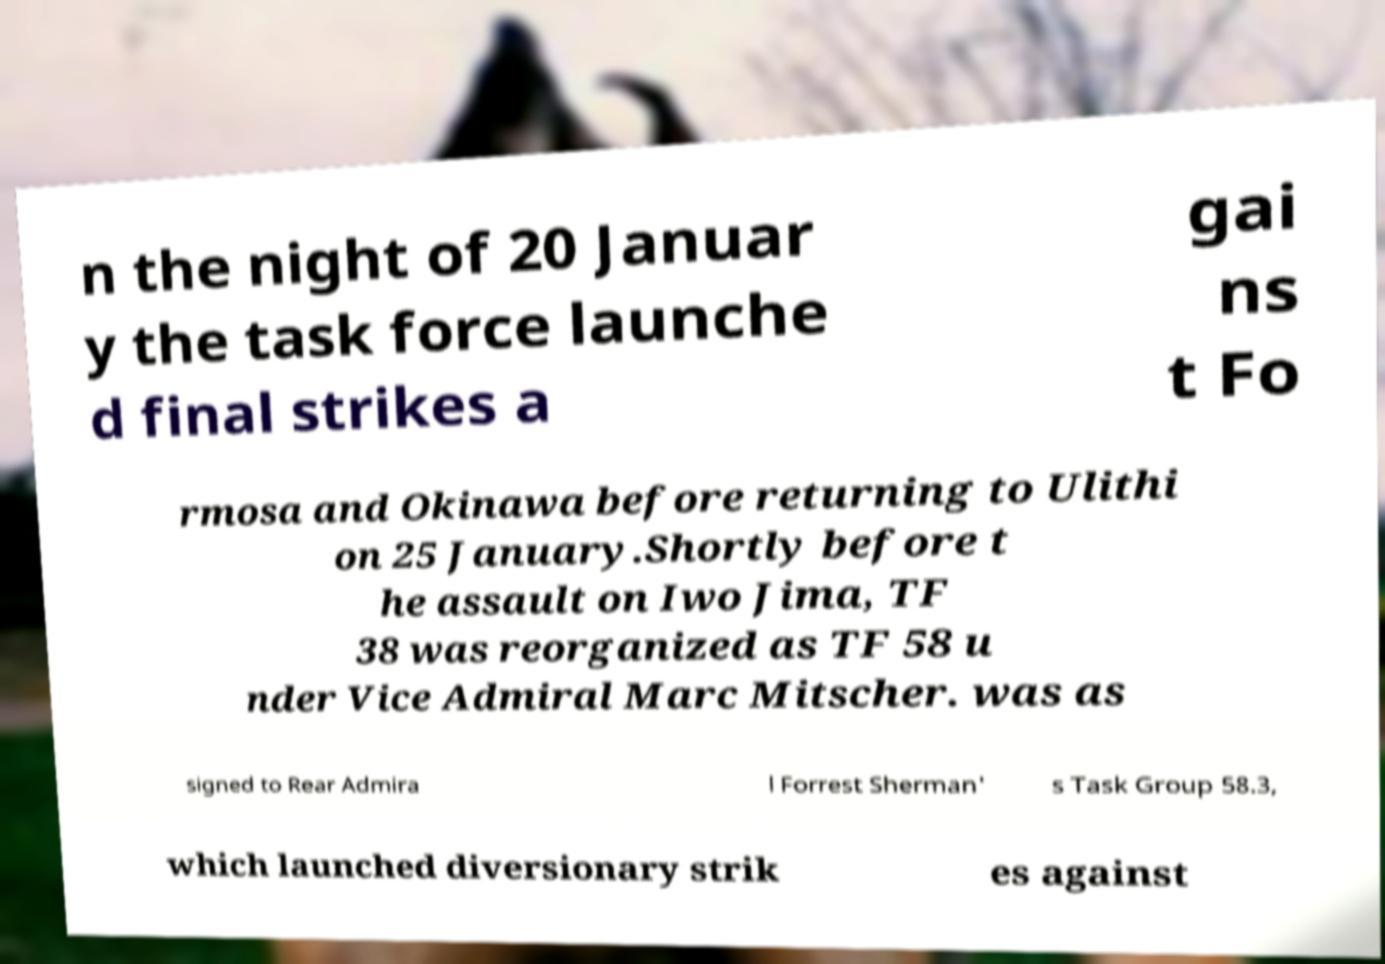For documentation purposes, I need the text within this image transcribed. Could you provide that? n the night of 20 Januar y the task force launche d final strikes a gai ns t Fo rmosa and Okinawa before returning to Ulithi on 25 January.Shortly before t he assault on Iwo Jima, TF 38 was reorganized as TF 58 u nder Vice Admiral Marc Mitscher. was as signed to Rear Admira l Forrest Sherman' s Task Group 58.3, which launched diversionary strik es against 